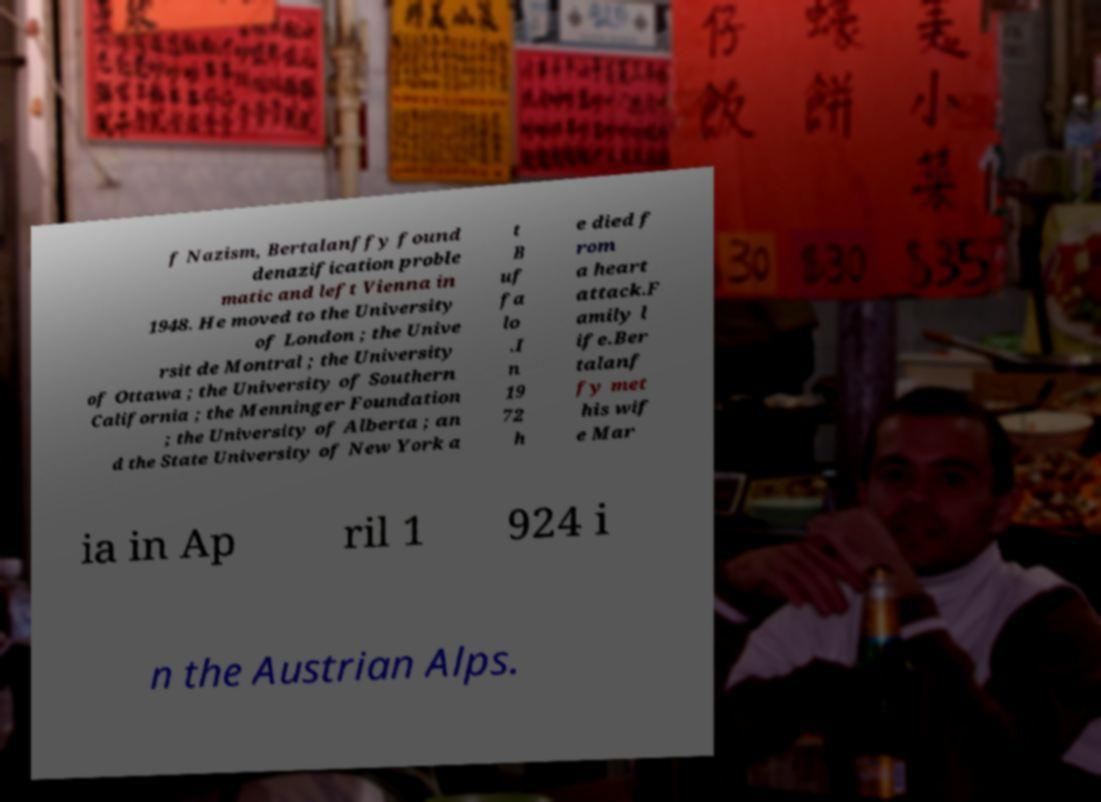Could you extract and type out the text from this image? f Nazism, Bertalanffy found denazification proble matic and left Vienna in 1948. He moved to the University of London ; the Unive rsit de Montral ; the University of Ottawa ; the University of Southern California ; the Menninger Foundation ; the University of Alberta ; an d the State University of New York a t B uf fa lo .I n 19 72 h e died f rom a heart attack.F amily l ife.Ber talanf fy met his wif e Mar ia in Ap ril 1 924 i n the Austrian Alps. 